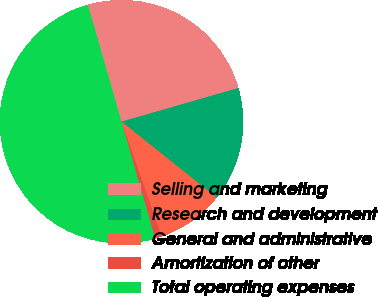Convert chart to OTSL. <chart><loc_0><loc_0><loc_500><loc_500><pie_chart><fcel>Selling and marketing<fcel>Research and development<fcel>General and administrative<fcel>Amortization of other<fcel>Total operating expenses<nl><fcel>25.0%<fcel>15.18%<fcel>8.93%<fcel>0.89%<fcel>50.0%<nl></chart> 